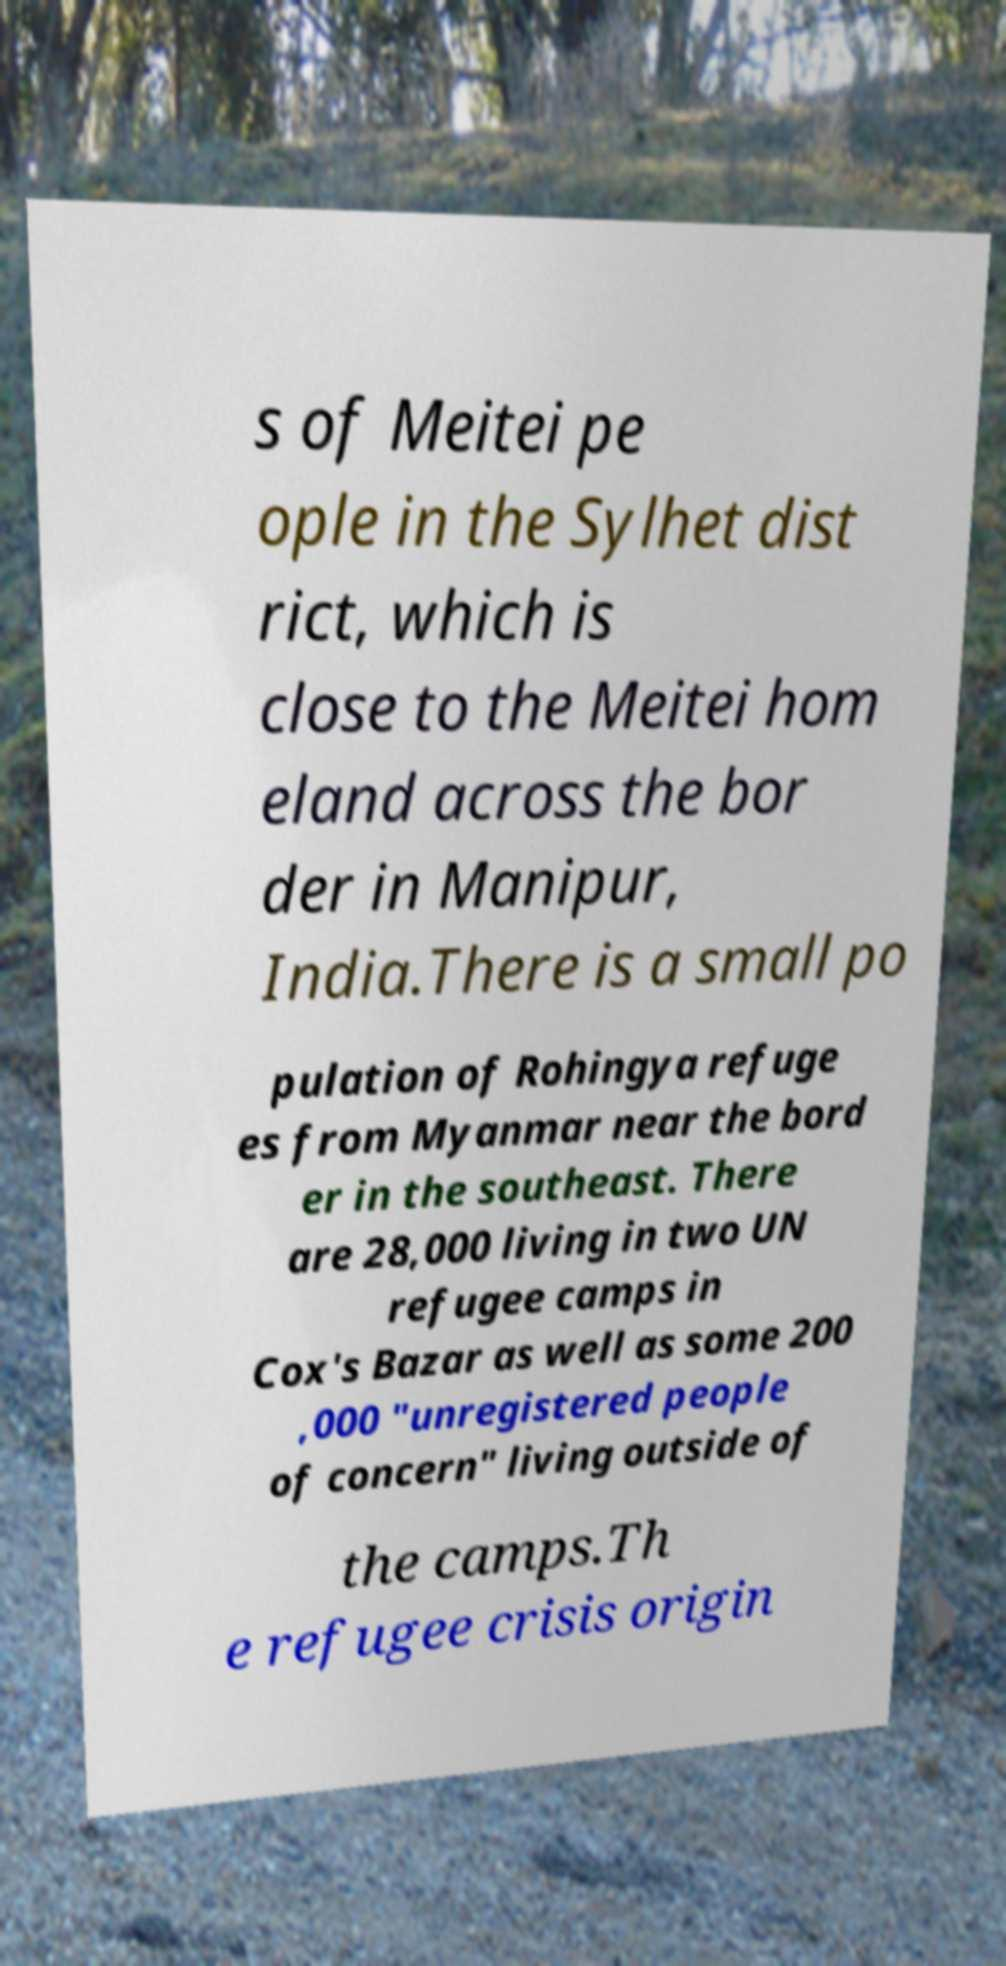For documentation purposes, I need the text within this image transcribed. Could you provide that? s of Meitei pe ople in the Sylhet dist rict, which is close to the Meitei hom eland across the bor der in Manipur, India.There is a small po pulation of Rohingya refuge es from Myanmar near the bord er in the southeast. There are 28,000 living in two UN refugee camps in Cox's Bazar as well as some 200 ,000 "unregistered people of concern" living outside of the camps.Th e refugee crisis origin 